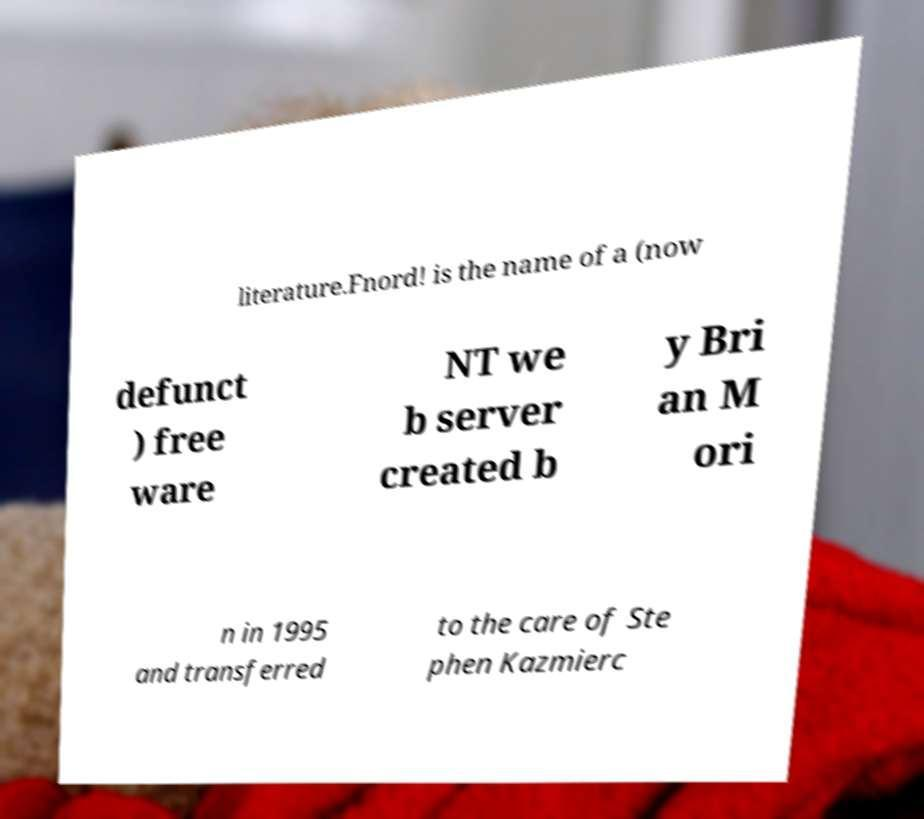Could you extract and type out the text from this image? literature.Fnord! is the name of a (now defunct ) free ware NT we b server created b y Bri an M ori n in 1995 and transferred to the care of Ste phen Kazmierc 